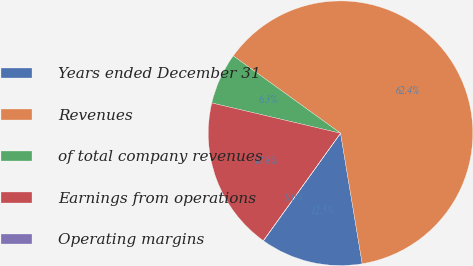Convert chart. <chart><loc_0><loc_0><loc_500><loc_500><pie_chart><fcel>Years ended December 31<fcel>Revenues<fcel>of total company revenues<fcel>Earnings from operations<fcel>Operating margins<nl><fcel>12.51%<fcel>62.43%<fcel>6.27%<fcel>18.75%<fcel>0.03%<nl></chart> 